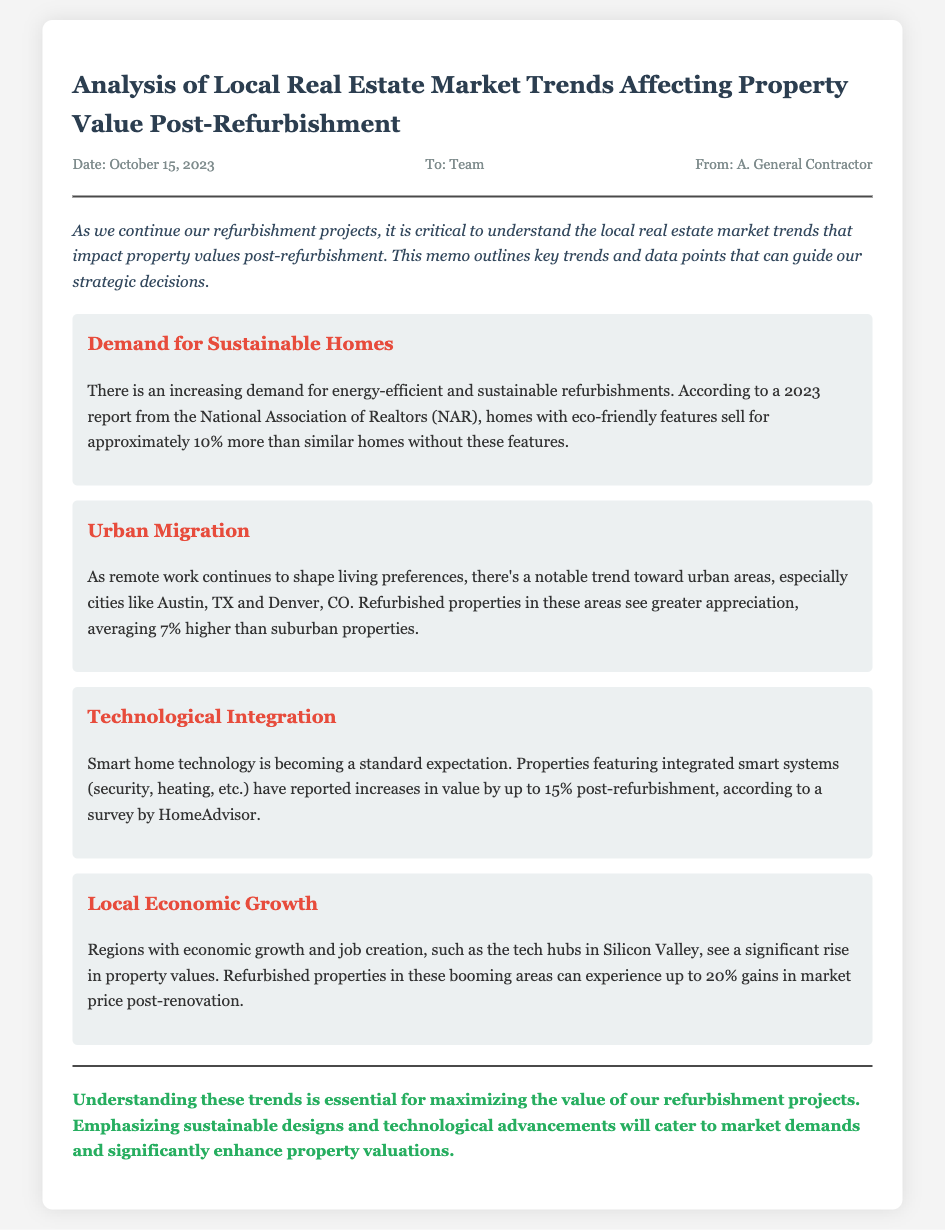What date was the memo issued? The date of the memo is mentioned in the document as October 15, 2023.
Answer: October 15, 2023 Which organization reported on sustainable home values? The National Association of Realtors (NAR) is cited as the source for the report on sustainable homes.
Answer: National Association of Realtors (NAR) How much more do homes with eco-friendly features sell for? The document states that homes with eco-friendly features sell for approximately 10% more.
Answer: 10% What is the average appreciation rate for refurbished properties in urban areas? The document indicates that refurbished properties in urban areas see greater appreciation, averaging 7% higher.
Answer: 7% According to HomeAdvisor, how much can integrated smart systems increase property value? The document notes that properties featuring integrated smart systems can report increases in value by up to 15%.
Answer: 15% What type of properties see a significant rise in value in Silicon Valley? The document refers to refurbished properties in Silicon Valley experiencing significant value rise.
Answer: Refurbished properties What essential aspect should be emphasized to maximize property valuations? The document concludes that emphasizing sustainable designs and technological advancements is essential.
Answer: Sustainable designs and technological advancements 